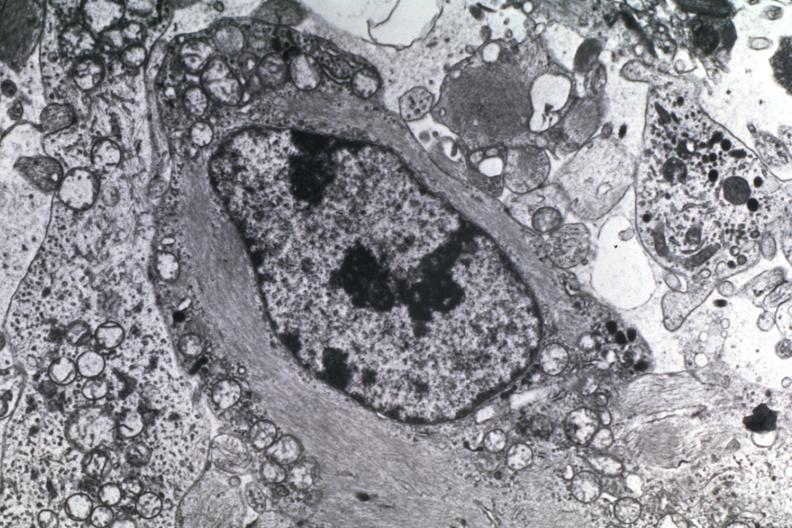s venous thrombosis present?
Answer the question using a single word or phrase. No 